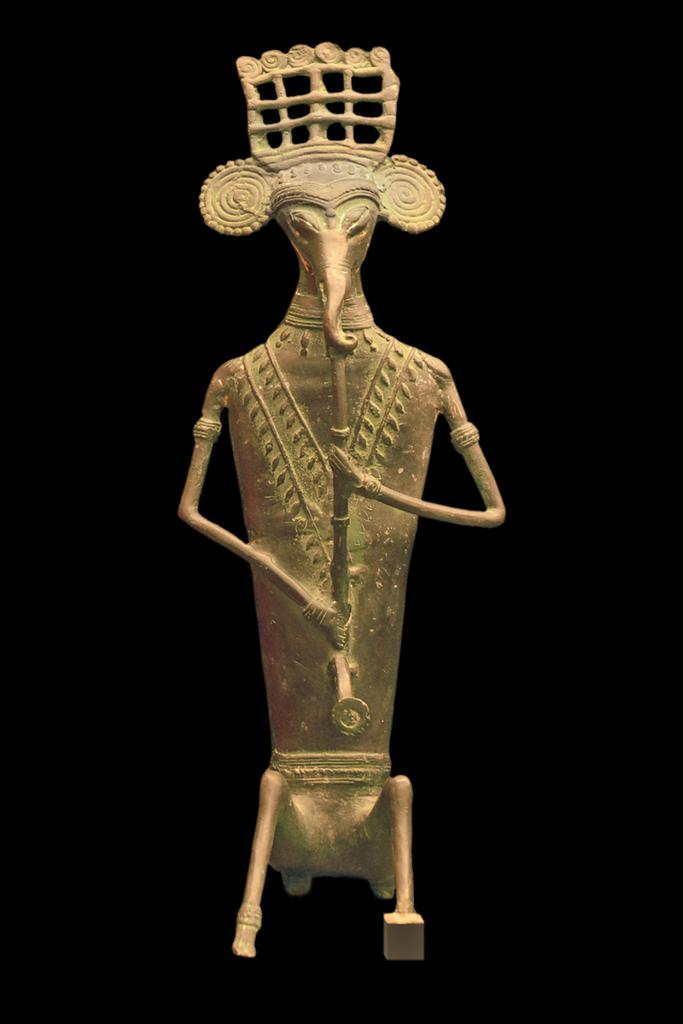What is the main subject in the center of the image? There is a statue in the center of the image. What type of pet can be seen sitting on the plate in the image? There is no plate or pet present in the image; it only features a statue. 